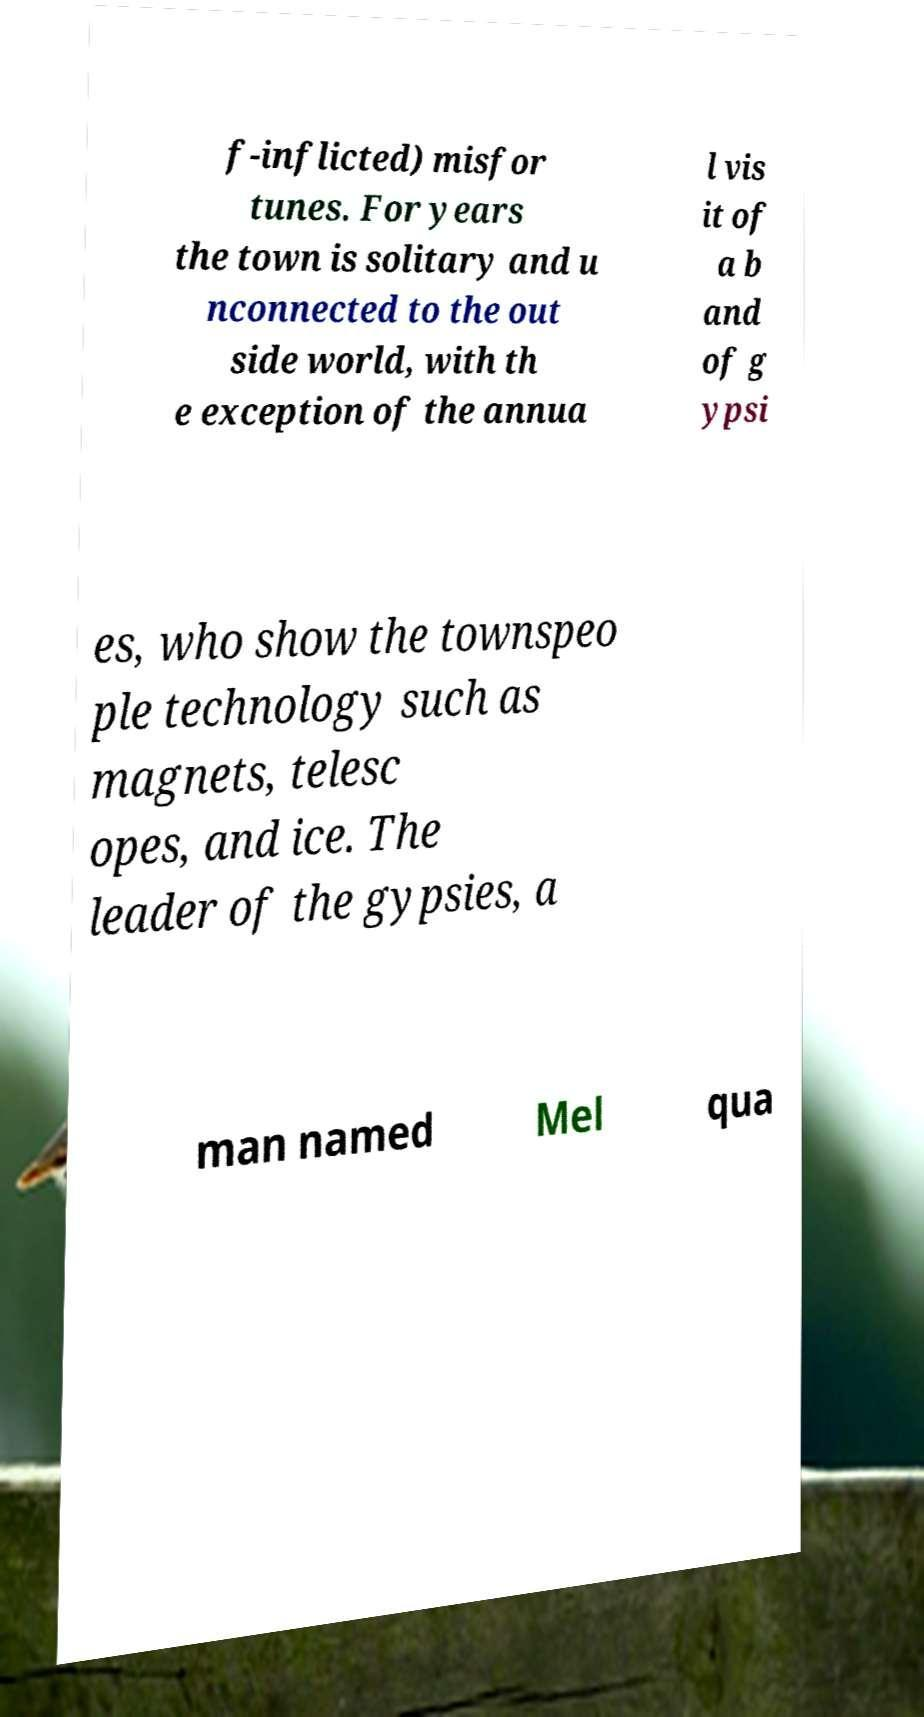Can you accurately transcribe the text from the provided image for me? f-inflicted) misfor tunes. For years the town is solitary and u nconnected to the out side world, with th e exception of the annua l vis it of a b and of g ypsi es, who show the townspeo ple technology such as magnets, telesc opes, and ice. The leader of the gypsies, a man named Mel qua 